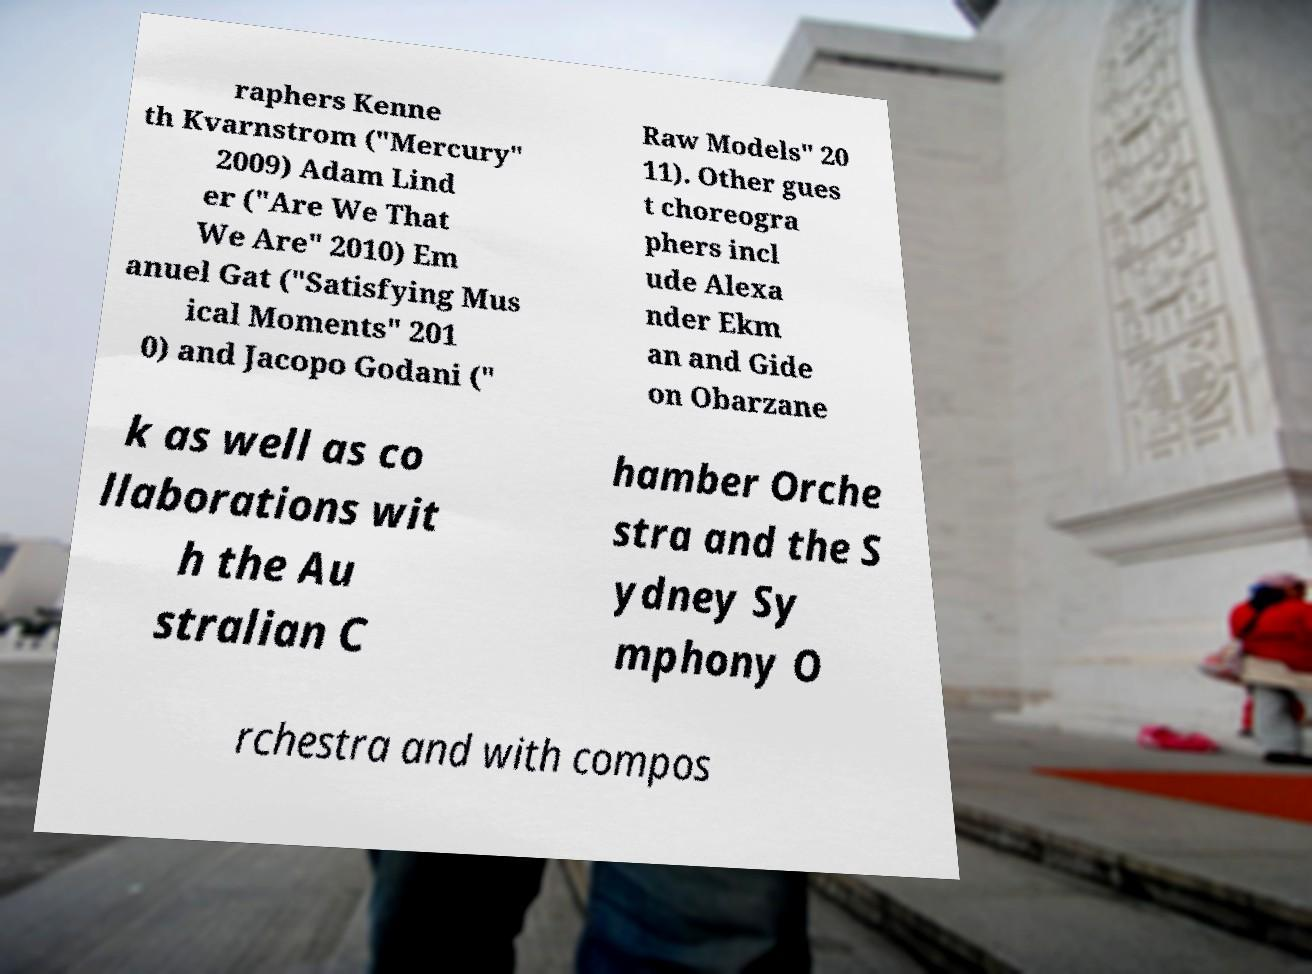I need the written content from this picture converted into text. Can you do that? raphers Kenne th Kvarnstrom ("Mercury" 2009) Adam Lind er ("Are We That We Are" 2010) Em anuel Gat ("Satisfying Mus ical Moments" 201 0) and Jacopo Godani (" Raw Models" 20 11). Other gues t choreogra phers incl ude Alexa nder Ekm an and Gide on Obarzane k as well as co llaborations wit h the Au stralian C hamber Orche stra and the S ydney Sy mphony O rchestra and with compos 